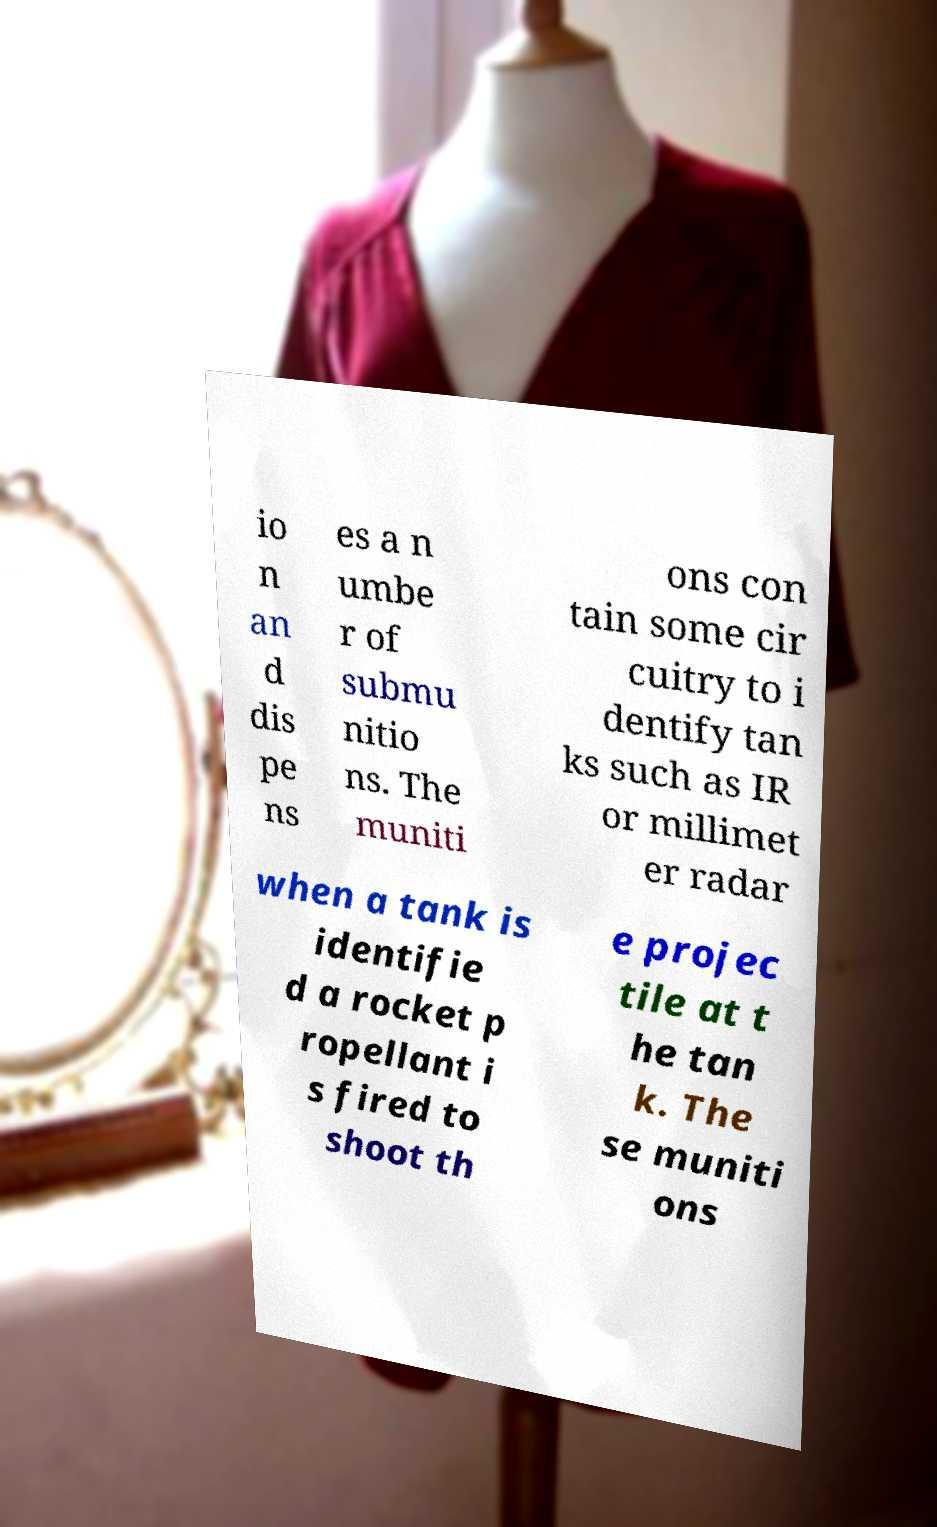Can you accurately transcribe the text from the provided image for me? io n an d dis pe ns es a n umbe r of submu nitio ns. The muniti ons con tain some cir cuitry to i dentify tan ks such as IR or millimet er radar when a tank is identifie d a rocket p ropellant i s fired to shoot th e projec tile at t he tan k. The se muniti ons 